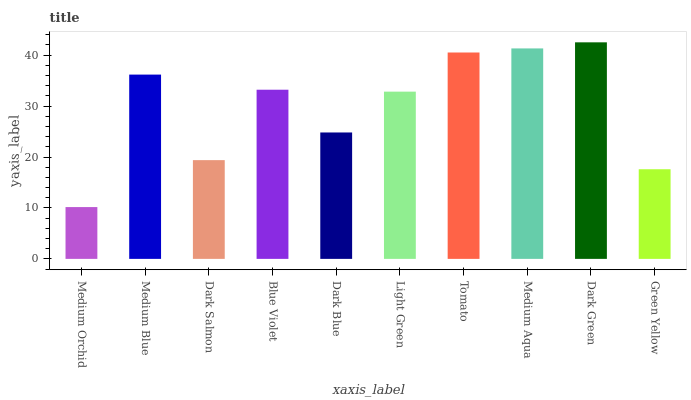Is Medium Blue the minimum?
Answer yes or no. No. Is Medium Blue the maximum?
Answer yes or no. No. Is Medium Blue greater than Medium Orchid?
Answer yes or no. Yes. Is Medium Orchid less than Medium Blue?
Answer yes or no. Yes. Is Medium Orchid greater than Medium Blue?
Answer yes or no. No. Is Medium Blue less than Medium Orchid?
Answer yes or no. No. Is Blue Violet the high median?
Answer yes or no. Yes. Is Light Green the low median?
Answer yes or no. Yes. Is Dark Green the high median?
Answer yes or no. No. Is Dark Salmon the low median?
Answer yes or no. No. 